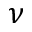Convert formula to latex. <formula><loc_0><loc_0><loc_500><loc_500>\nu</formula> 